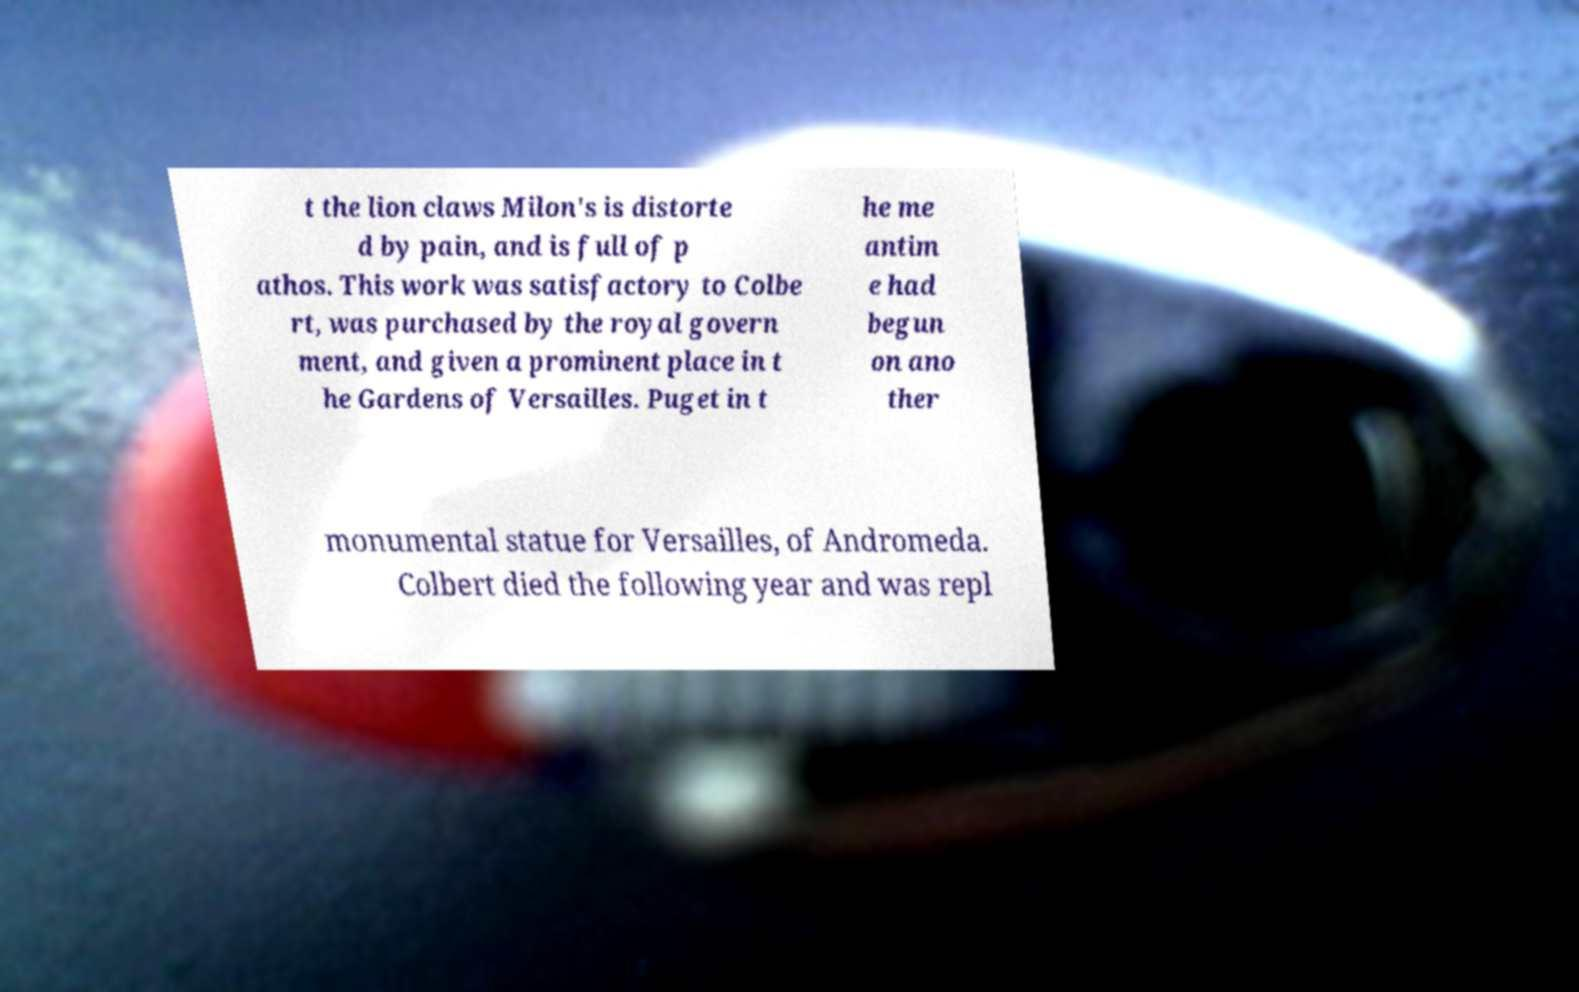I need the written content from this picture converted into text. Can you do that? t the lion claws Milon's is distorte d by pain, and is full of p athos. This work was satisfactory to Colbe rt, was purchased by the royal govern ment, and given a prominent place in t he Gardens of Versailles. Puget in t he me antim e had begun on ano ther monumental statue for Versailles, of Andromeda. Colbert died the following year and was repl 